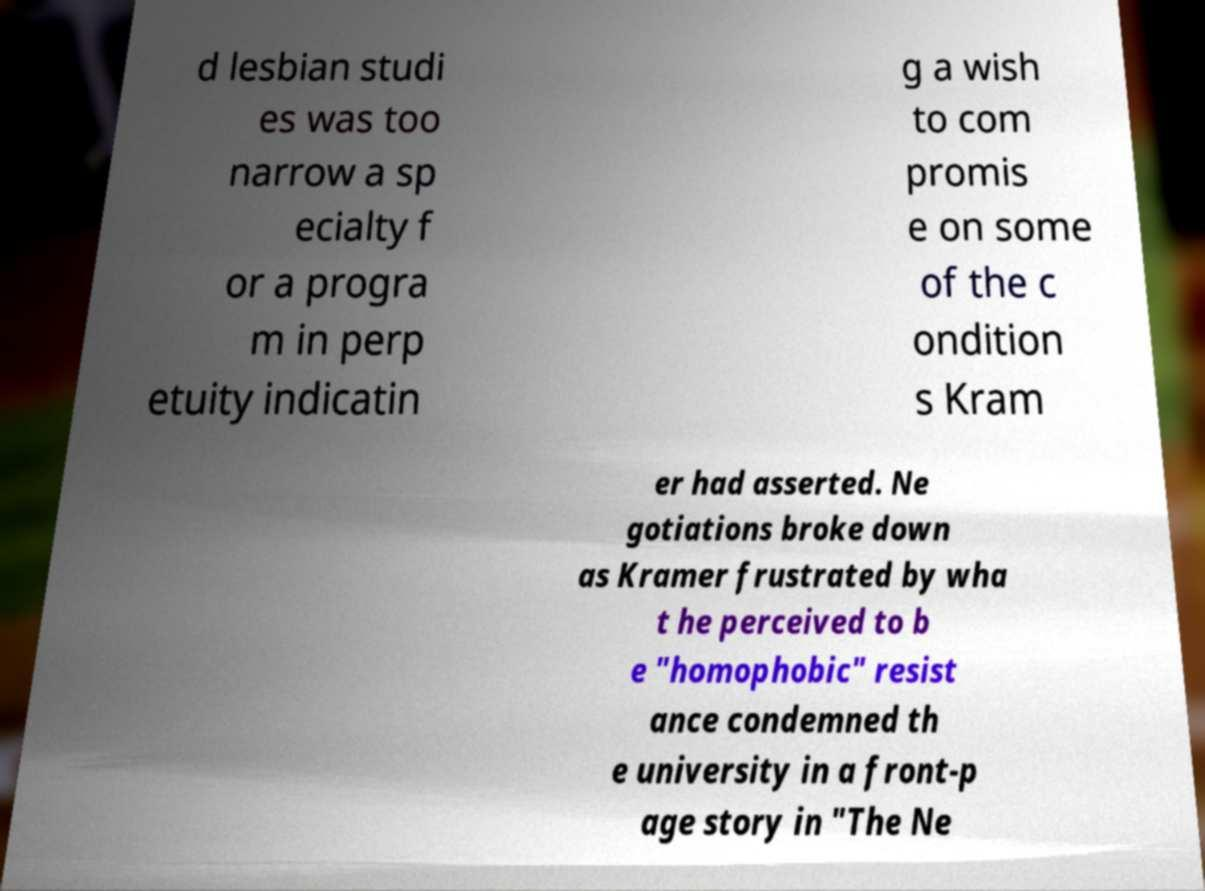What messages or text are displayed in this image? I need them in a readable, typed format. d lesbian studi es was too narrow a sp ecialty f or a progra m in perp etuity indicatin g a wish to com promis e on some of the c ondition s Kram er had asserted. Ne gotiations broke down as Kramer frustrated by wha t he perceived to b e "homophobic" resist ance condemned th e university in a front-p age story in "The Ne 